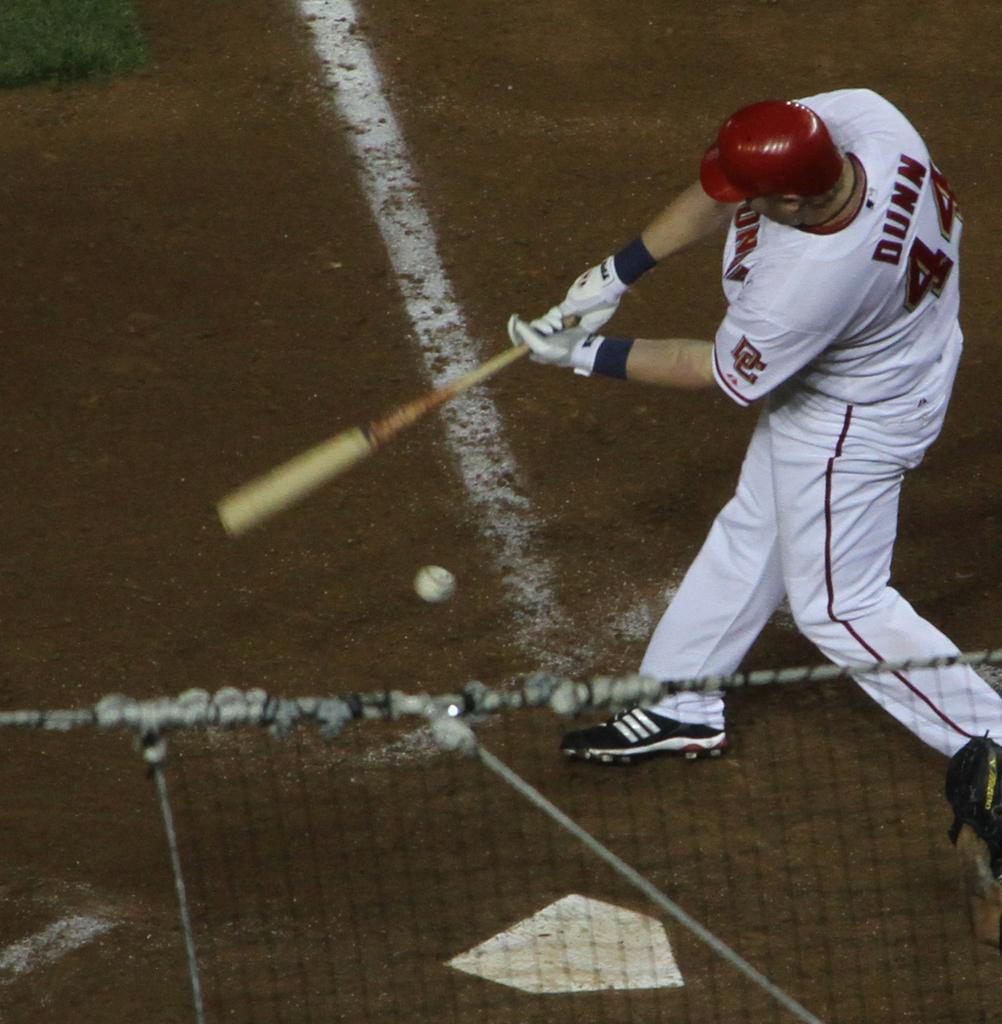<image>
Describe the image concisely. Dunn is taking his turn at bat and swinging at the ball. 